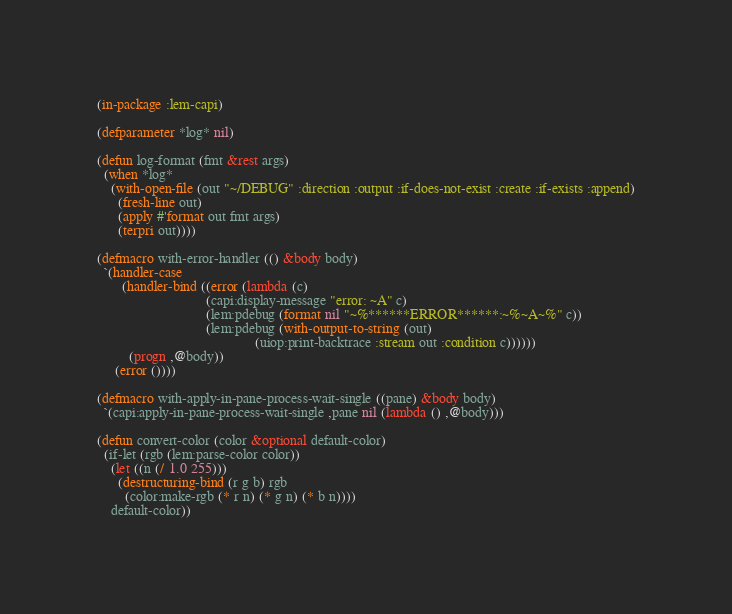Convert code to text. <code><loc_0><loc_0><loc_500><loc_500><_Lisp_>(in-package :lem-capi)

(defparameter *log* nil)

(defun log-format (fmt &rest args)
  (when *log*
    (with-open-file (out "~/DEBUG" :direction :output :if-does-not-exist :create :if-exists :append)
      (fresh-line out)
      (apply #'format out fmt args)
      (terpri out))))

(defmacro with-error-handler (() &body body)
  `(handler-case
       (handler-bind ((error (lambda (c)
                               (capi:display-message "error: ~A" c)
                               (lem:pdebug (format nil "~%******ERROR******:~%~A~%" c))
                               (lem:pdebug (with-output-to-string (out)
                                             (uiop:print-backtrace :stream out :condition c))))))
         (progn ,@body))
     (error ())))

(defmacro with-apply-in-pane-process-wait-single ((pane) &body body)
  `(capi:apply-in-pane-process-wait-single ,pane nil (lambda () ,@body)))

(defun convert-color (color &optional default-color)
  (if-let (rgb (lem:parse-color color))
    (let ((n (/ 1.0 255)))
      (destructuring-bind (r g b) rgb
        (color:make-rgb (* r n) (* g n) (* b n))))
    default-color))
</code> 